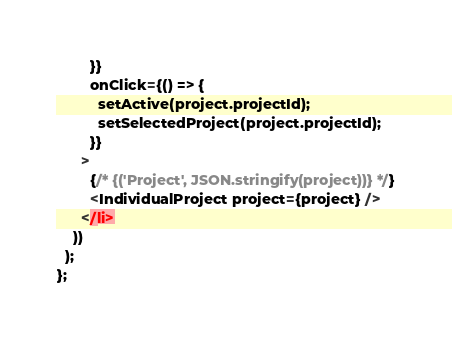<code> <loc_0><loc_0><loc_500><loc_500><_JavaScript_>        }}
        onClick={() => {
          setActive(project.projectId);
          setSelectedProject(project.projectId);
        }}
      >
        {/* {('Project', JSON.stringify(project))} */}
        <IndividualProject project={project} />
      </li>
    ))
  );
};
</code> 